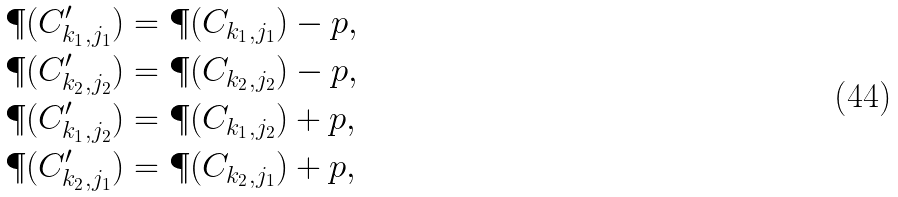<formula> <loc_0><loc_0><loc_500><loc_500>\P ( C ^ { \prime } _ { k _ { 1 } , j _ { 1 } } ) & = \P ( C _ { k _ { 1 } , j _ { 1 } } ) - p , \\ \P ( C ^ { \prime } _ { k _ { 2 } , j _ { 2 } } ) & = \P ( C _ { k _ { 2 } , j _ { 2 } } ) - p , \\ \P ( C ^ { \prime } _ { k _ { 1 } , j _ { 2 } } ) & = \P ( C _ { k _ { 1 } , j _ { 2 } } ) + p , \\ \P ( C ^ { \prime } _ { k _ { 2 } , j _ { 1 } } ) & = \P ( C _ { k _ { 2 } , j _ { 1 } } ) + p ,</formula> 